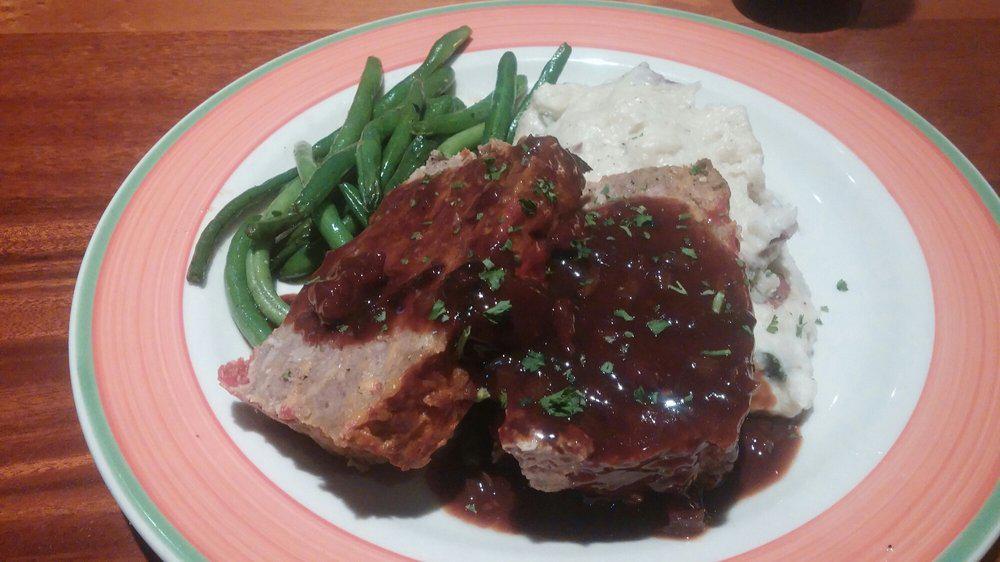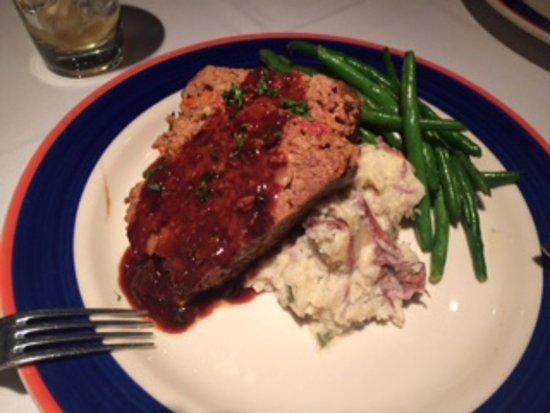The first image is the image on the left, the second image is the image on the right. For the images displayed, is the sentence "The food in the image on the right is being served in a blue and white dish." factually correct? Answer yes or no. Yes. The first image is the image on the left, the second image is the image on the right. Analyze the images presented: Is the assertion "At least one image shows green beans next to meatloaf on a plate, and one plate has a royal blue band around it rimmed with red." valid? Answer yes or no. Yes. 